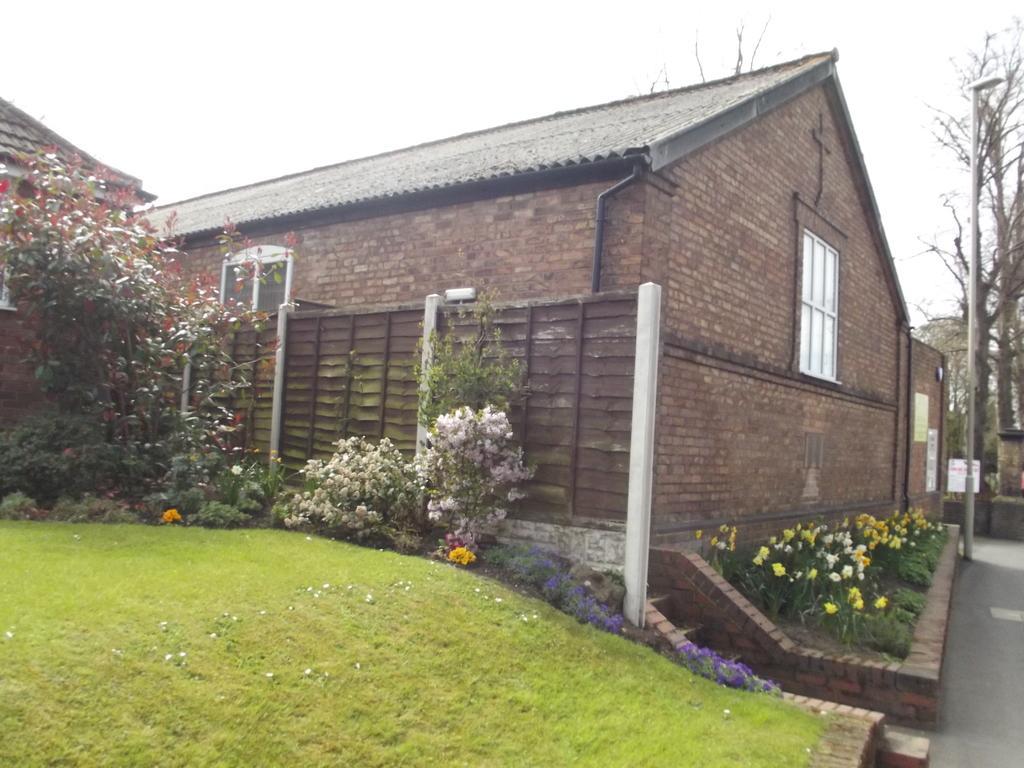Can you describe this image briefly? In this image we can see a house, plants, flowers, grass and other objects. On the right side of the image there are poles, trees and other objects. At the bottom of the image there is the grass. At the top of there is the sky. 